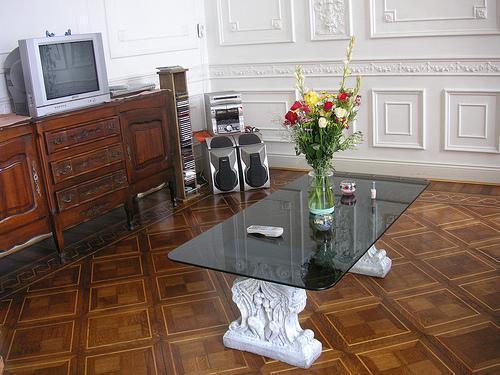How many stereo speakers are present?
Give a very brief answer. 2. How many drawers are under the tv?
Give a very brief answer. 3. How many pink candles are there?
Give a very brief answer. 1. 